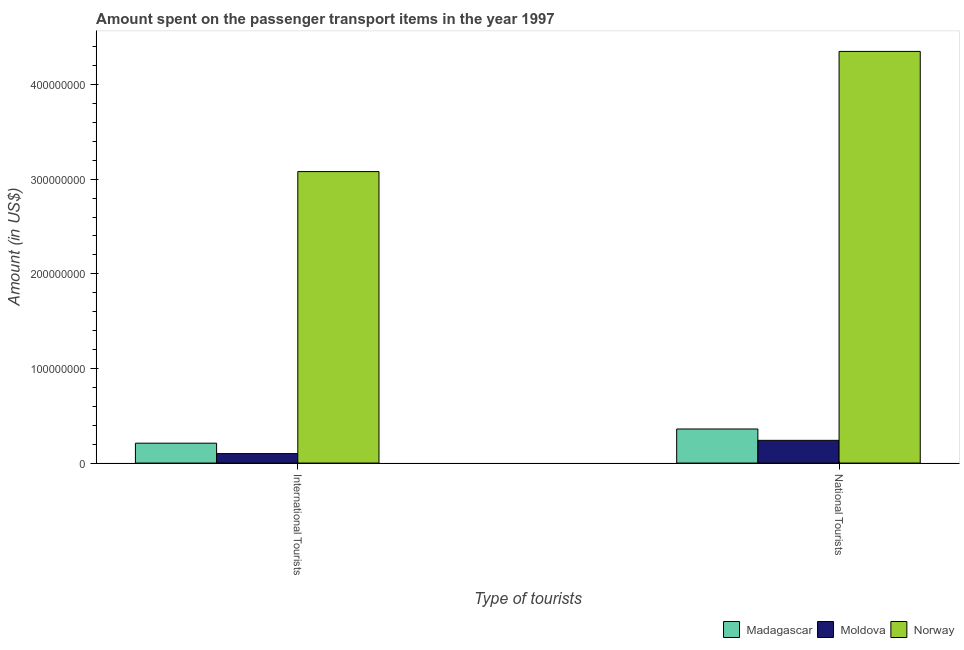How many groups of bars are there?
Keep it short and to the point. 2. Are the number of bars per tick equal to the number of legend labels?
Offer a very short reply. Yes. Are the number of bars on each tick of the X-axis equal?
Provide a short and direct response. Yes. What is the label of the 2nd group of bars from the left?
Provide a short and direct response. National Tourists. What is the amount spent on transport items of national tourists in Norway?
Provide a succinct answer. 4.35e+08. Across all countries, what is the maximum amount spent on transport items of international tourists?
Provide a short and direct response. 3.08e+08. Across all countries, what is the minimum amount spent on transport items of international tourists?
Offer a very short reply. 1.00e+07. In which country was the amount spent on transport items of national tourists maximum?
Ensure brevity in your answer.  Norway. In which country was the amount spent on transport items of international tourists minimum?
Ensure brevity in your answer.  Moldova. What is the total amount spent on transport items of national tourists in the graph?
Offer a very short reply. 4.95e+08. What is the difference between the amount spent on transport items of international tourists in Moldova and that in Madagascar?
Ensure brevity in your answer.  -1.10e+07. What is the difference between the amount spent on transport items of national tourists in Norway and the amount spent on transport items of international tourists in Moldova?
Offer a terse response. 4.25e+08. What is the average amount spent on transport items of international tourists per country?
Your answer should be compact. 1.13e+08. What is the difference between the amount spent on transport items of international tourists and amount spent on transport items of national tourists in Norway?
Your response must be concise. -1.27e+08. In how many countries, is the amount spent on transport items of international tourists greater than 200000000 US$?
Your answer should be very brief. 1. What is the ratio of the amount spent on transport items of national tourists in Norway to that in Moldova?
Your response must be concise. 18.12. Is the amount spent on transport items of international tourists in Norway less than that in Madagascar?
Ensure brevity in your answer.  No. What does the 1st bar from the left in International Tourists represents?
Ensure brevity in your answer.  Madagascar. What does the 2nd bar from the right in National Tourists represents?
Ensure brevity in your answer.  Moldova. How many bars are there?
Your response must be concise. 6. How many countries are there in the graph?
Give a very brief answer. 3. What is the difference between two consecutive major ticks on the Y-axis?
Offer a very short reply. 1.00e+08. Does the graph contain any zero values?
Your answer should be compact. No. Does the graph contain grids?
Offer a terse response. No. Where does the legend appear in the graph?
Offer a very short reply. Bottom right. What is the title of the graph?
Offer a very short reply. Amount spent on the passenger transport items in the year 1997. Does "Marshall Islands" appear as one of the legend labels in the graph?
Keep it short and to the point. No. What is the label or title of the X-axis?
Provide a short and direct response. Type of tourists. What is the label or title of the Y-axis?
Provide a succinct answer. Amount (in US$). What is the Amount (in US$) in Madagascar in International Tourists?
Give a very brief answer. 2.10e+07. What is the Amount (in US$) in Norway in International Tourists?
Offer a very short reply. 3.08e+08. What is the Amount (in US$) in Madagascar in National Tourists?
Make the answer very short. 3.60e+07. What is the Amount (in US$) in Moldova in National Tourists?
Provide a succinct answer. 2.40e+07. What is the Amount (in US$) of Norway in National Tourists?
Make the answer very short. 4.35e+08. Across all Type of tourists, what is the maximum Amount (in US$) of Madagascar?
Provide a succinct answer. 3.60e+07. Across all Type of tourists, what is the maximum Amount (in US$) of Moldova?
Your response must be concise. 2.40e+07. Across all Type of tourists, what is the maximum Amount (in US$) of Norway?
Offer a terse response. 4.35e+08. Across all Type of tourists, what is the minimum Amount (in US$) in Madagascar?
Make the answer very short. 2.10e+07. Across all Type of tourists, what is the minimum Amount (in US$) of Moldova?
Provide a short and direct response. 1.00e+07. Across all Type of tourists, what is the minimum Amount (in US$) in Norway?
Keep it short and to the point. 3.08e+08. What is the total Amount (in US$) of Madagascar in the graph?
Offer a terse response. 5.70e+07. What is the total Amount (in US$) of Moldova in the graph?
Ensure brevity in your answer.  3.40e+07. What is the total Amount (in US$) in Norway in the graph?
Offer a very short reply. 7.43e+08. What is the difference between the Amount (in US$) in Madagascar in International Tourists and that in National Tourists?
Your response must be concise. -1.50e+07. What is the difference between the Amount (in US$) of Moldova in International Tourists and that in National Tourists?
Your response must be concise. -1.40e+07. What is the difference between the Amount (in US$) of Norway in International Tourists and that in National Tourists?
Your answer should be very brief. -1.27e+08. What is the difference between the Amount (in US$) of Madagascar in International Tourists and the Amount (in US$) of Norway in National Tourists?
Your answer should be compact. -4.14e+08. What is the difference between the Amount (in US$) of Moldova in International Tourists and the Amount (in US$) of Norway in National Tourists?
Provide a succinct answer. -4.25e+08. What is the average Amount (in US$) of Madagascar per Type of tourists?
Offer a very short reply. 2.85e+07. What is the average Amount (in US$) in Moldova per Type of tourists?
Make the answer very short. 1.70e+07. What is the average Amount (in US$) of Norway per Type of tourists?
Offer a terse response. 3.72e+08. What is the difference between the Amount (in US$) of Madagascar and Amount (in US$) of Moldova in International Tourists?
Offer a terse response. 1.10e+07. What is the difference between the Amount (in US$) in Madagascar and Amount (in US$) in Norway in International Tourists?
Give a very brief answer. -2.87e+08. What is the difference between the Amount (in US$) in Moldova and Amount (in US$) in Norway in International Tourists?
Your response must be concise. -2.98e+08. What is the difference between the Amount (in US$) of Madagascar and Amount (in US$) of Moldova in National Tourists?
Offer a terse response. 1.20e+07. What is the difference between the Amount (in US$) in Madagascar and Amount (in US$) in Norway in National Tourists?
Offer a very short reply. -3.99e+08. What is the difference between the Amount (in US$) in Moldova and Amount (in US$) in Norway in National Tourists?
Make the answer very short. -4.11e+08. What is the ratio of the Amount (in US$) in Madagascar in International Tourists to that in National Tourists?
Ensure brevity in your answer.  0.58. What is the ratio of the Amount (in US$) of Moldova in International Tourists to that in National Tourists?
Offer a very short reply. 0.42. What is the ratio of the Amount (in US$) of Norway in International Tourists to that in National Tourists?
Your answer should be very brief. 0.71. What is the difference between the highest and the second highest Amount (in US$) in Madagascar?
Your response must be concise. 1.50e+07. What is the difference between the highest and the second highest Amount (in US$) in Moldova?
Ensure brevity in your answer.  1.40e+07. What is the difference between the highest and the second highest Amount (in US$) of Norway?
Provide a short and direct response. 1.27e+08. What is the difference between the highest and the lowest Amount (in US$) in Madagascar?
Your response must be concise. 1.50e+07. What is the difference between the highest and the lowest Amount (in US$) in Moldova?
Ensure brevity in your answer.  1.40e+07. What is the difference between the highest and the lowest Amount (in US$) of Norway?
Your answer should be compact. 1.27e+08. 